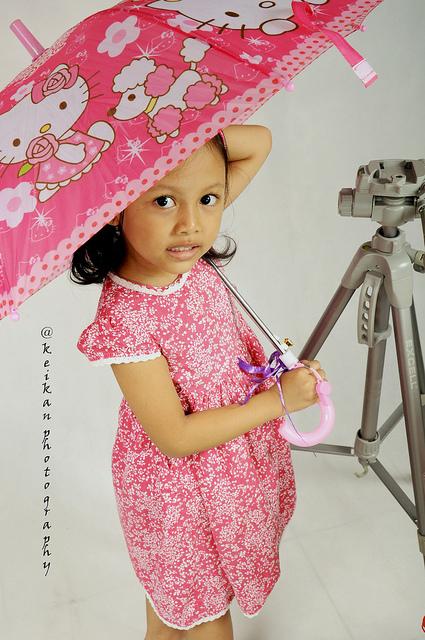What is the main color on the umbrella?
Give a very brief answer. Pink. What character is on the umbrella?
Concise answer only. Hello kitty. Is the umbrella open?
Give a very brief answer. Yes. 